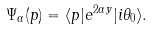<formula> <loc_0><loc_0><loc_500><loc_500>\Psi _ { \alpha } ( p ) = \langle p | e ^ { 2 \alpha y } | i \theta _ { 0 } \rangle .</formula> 